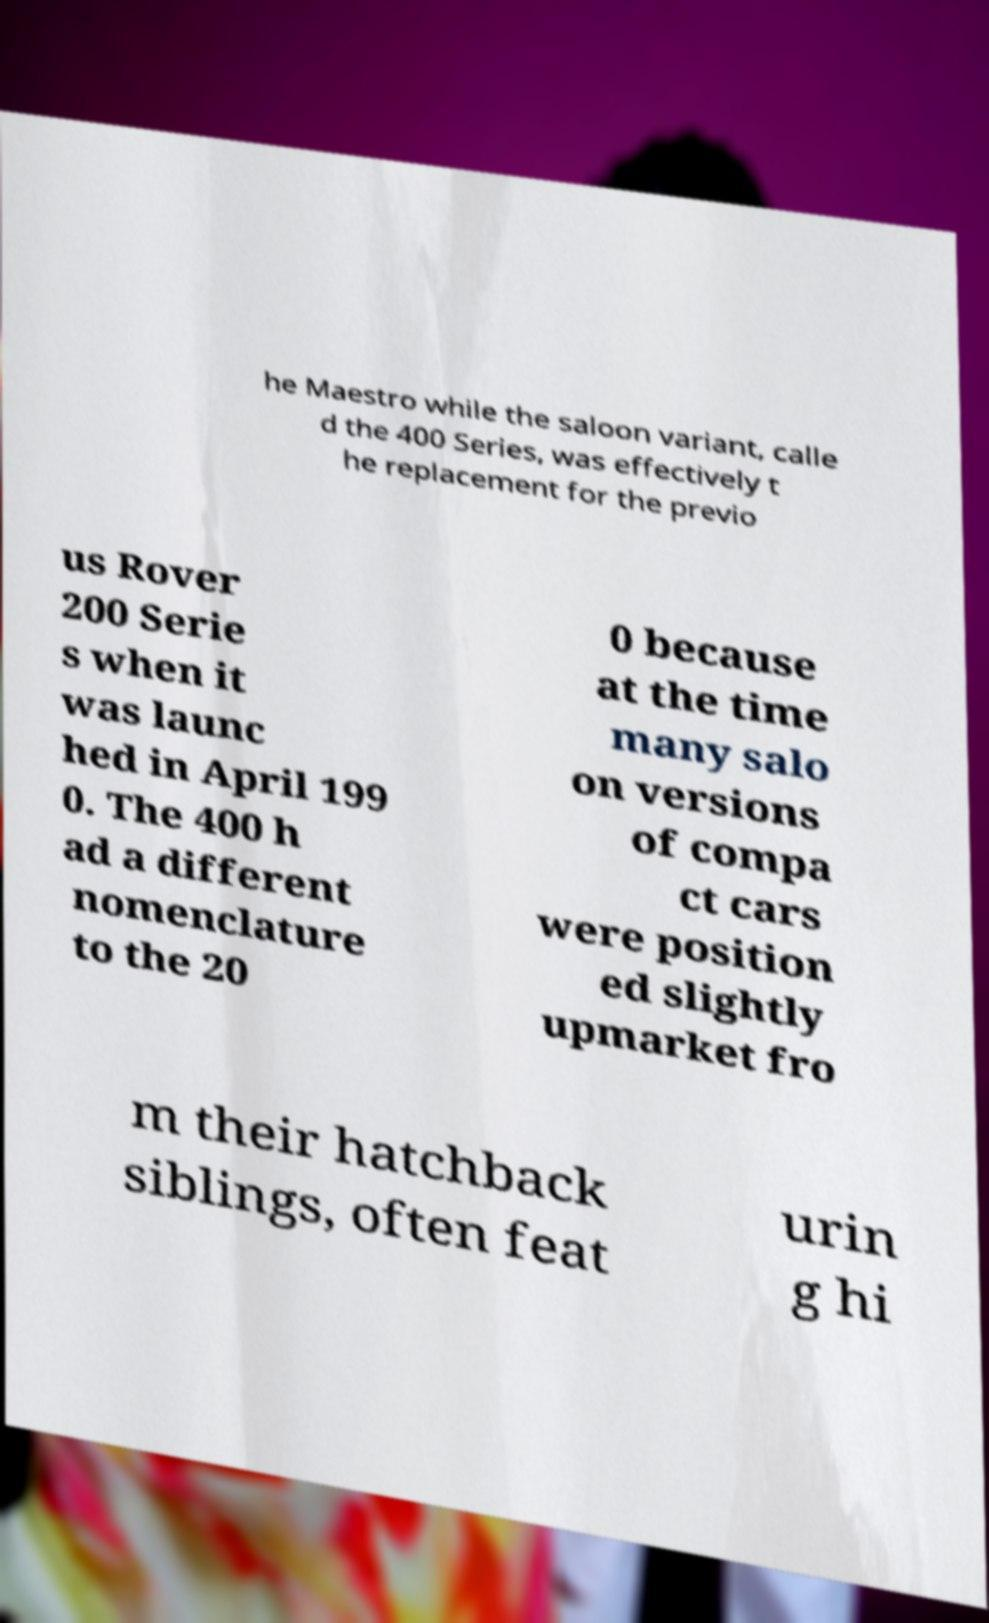Could you extract and type out the text from this image? he Maestro while the saloon variant, calle d the 400 Series, was effectively t he replacement for the previo us Rover 200 Serie s when it was launc hed in April 199 0. The 400 h ad a different nomenclature to the 20 0 because at the time many salo on versions of compa ct cars were position ed slightly upmarket fro m their hatchback siblings, often feat urin g hi 